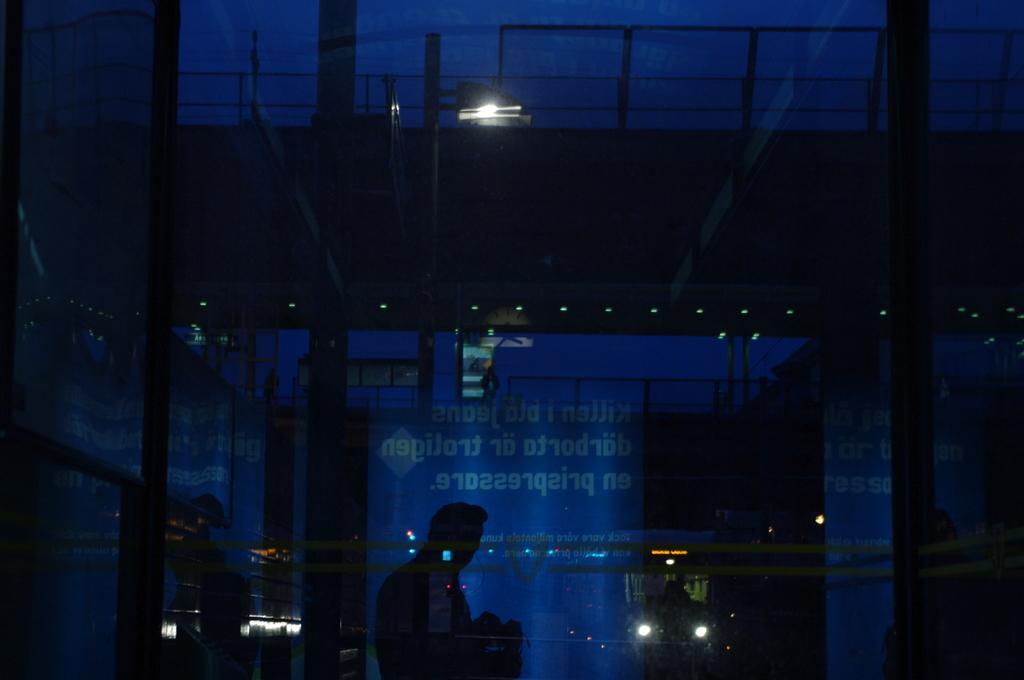Could you give a brief overview of what you see in this image? In this image in the front there is a glass and behind the glass there is a person standing and there is a banner with some text written on it and there are lights. 